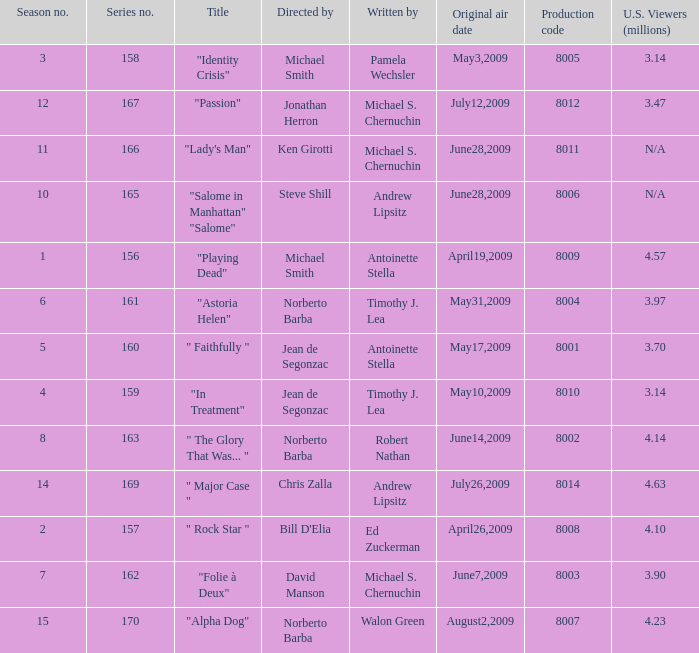Which is the biggest production code? 8014.0. Can you parse all the data within this table? {'header': ['Season no.', 'Series no.', 'Title', 'Directed by', 'Written by', 'Original air date', 'Production code', 'U.S. Viewers (millions)'], 'rows': [['3', '158', '"Identity Crisis"', 'Michael Smith', 'Pamela Wechsler', 'May3,2009', '8005', '3.14'], ['12', '167', '"Passion"', 'Jonathan Herron', 'Michael S. Chernuchin', 'July12,2009', '8012', '3.47'], ['11', '166', '"Lady\'s Man"', 'Ken Girotti', 'Michael S. Chernuchin', 'June28,2009', '8011', 'N/A'], ['10', '165', '"Salome in Manhattan" "Salome"', 'Steve Shill', 'Andrew Lipsitz', 'June28,2009', '8006', 'N/A'], ['1', '156', '"Playing Dead"', 'Michael Smith', 'Antoinette Stella', 'April19,2009', '8009', '4.57'], ['6', '161', '"Astoria Helen"', 'Norberto Barba', 'Timothy J. Lea', 'May31,2009', '8004', '3.97'], ['5', '160', '" Faithfully "', 'Jean de Segonzac', 'Antoinette Stella', 'May17,2009', '8001', '3.70'], ['4', '159', '"In Treatment"', 'Jean de Segonzac', 'Timothy J. Lea', 'May10,2009', '8010', '3.14'], ['8', '163', '" The Glory That Was... "', 'Norberto Barba', 'Robert Nathan', 'June14,2009', '8002', '4.14'], ['14', '169', '" Major Case "', 'Chris Zalla', 'Andrew Lipsitz', 'July26,2009', '8014', '4.63'], ['2', '157', '" Rock Star "', "Bill D'Elia", 'Ed Zuckerman', 'April26,2009', '8008', '4.10'], ['7', '162', '"Folie à Deux"', 'David Manson', 'Michael S. Chernuchin', 'June7,2009', '8003', '3.90'], ['15', '170', '"Alpha Dog"', 'Norberto Barba', 'Walon Green', 'August2,2009', '8007', '4.23']]} 